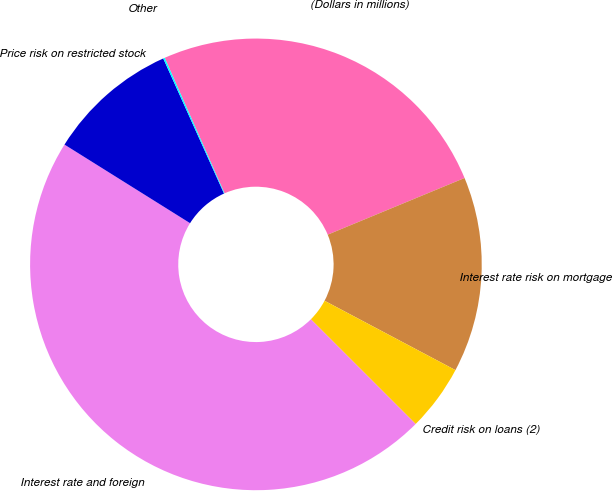Convert chart. <chart><loc_0><loc_0><loc_500><loc_500><pie_chart><fcel>(Dollars in millions)<fcel>Interest rate risk on mortgage<fcel>Credit risk on loans (2)<fcel>Interest rate and foreign<fcel>Price risk on restricted stock<fcel>Other<nl><fcel>25.37%<fcel>14.0%<fcel>4.74%<fcel>46.4%<fcel>9.37%<fcel>0.11%<nl></chart> 